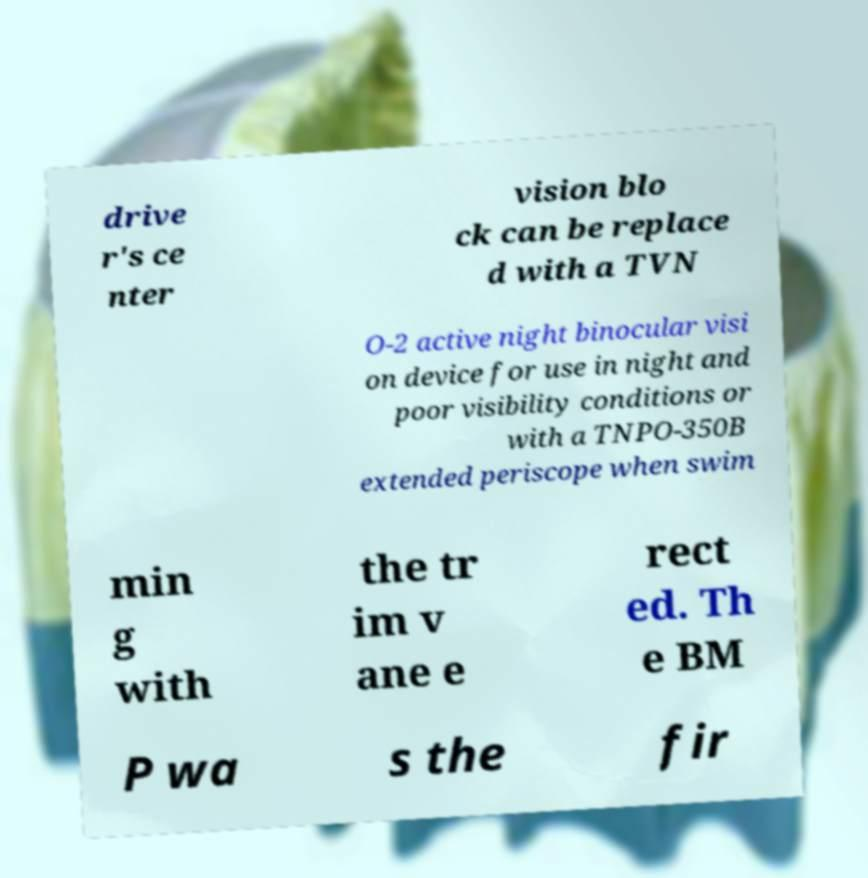Could you assist in decoding the text presented in this image and type it out clearly? drive r's ce nter vision blo ck can be replace d with a TVN O-2 active night binocular visi on device for use in night and poor visibility conditions or with a TNPO-350B extended periscope when swim min g with the tr im v ane e rect ed. Th e BM P wa s the fir 